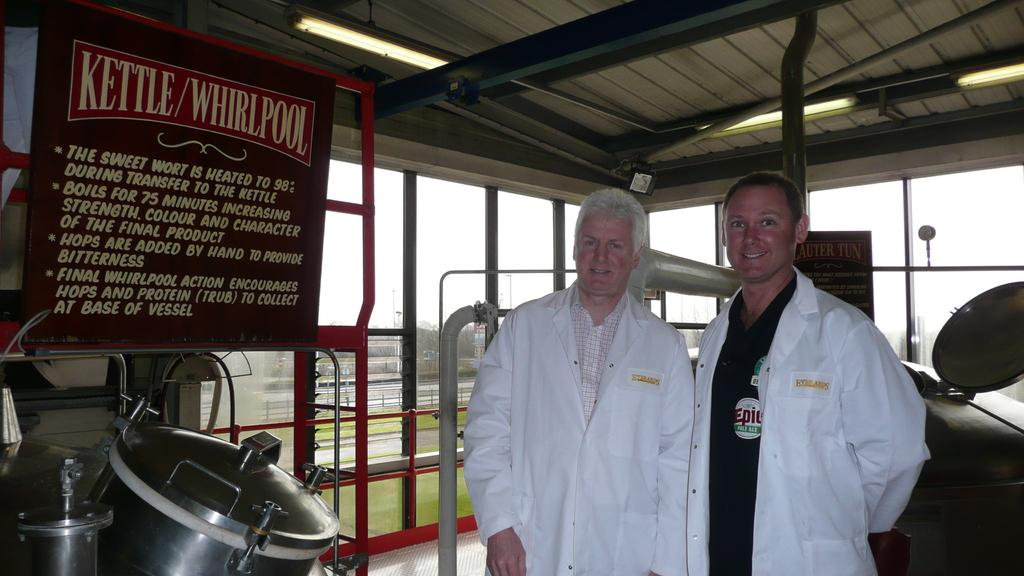Provide a one-sentence caption for the provided image. Two men in white lab coats are standing next to a kettle in a brewery. 